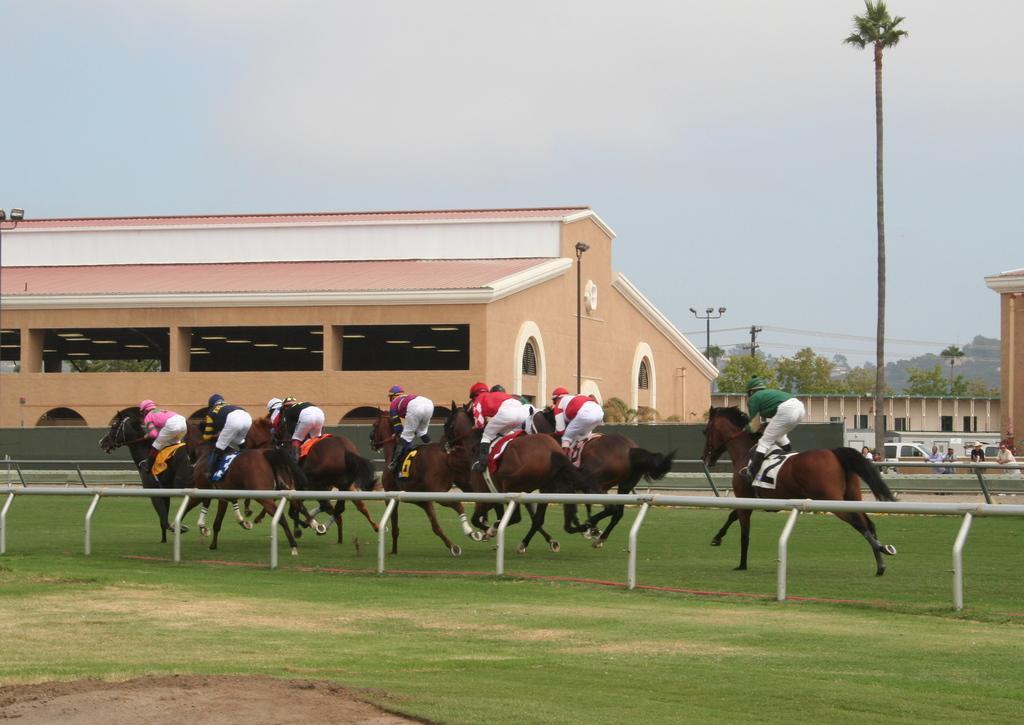Please provide a concise description of this image. In this image I can see there are few persons riding on horse on the ground , at the top I can see the sky, in the middle I can see the building and trees and poles 